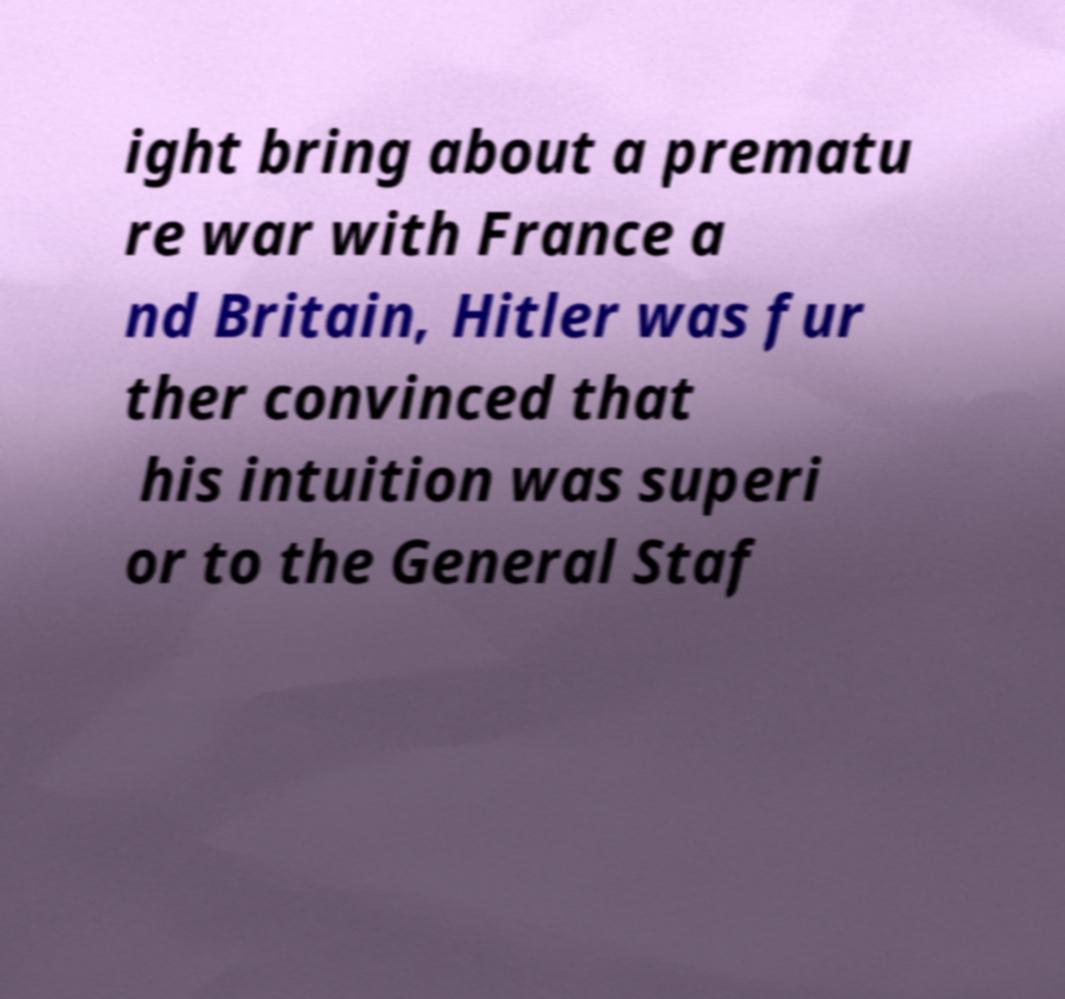For documentation purposes, I need the text within this image transcribed. Could you provide that? ight bring about a prematu re war with France a nd Britain, Hitler was fur ther convinced that his intuition was superi or to the General Staf 